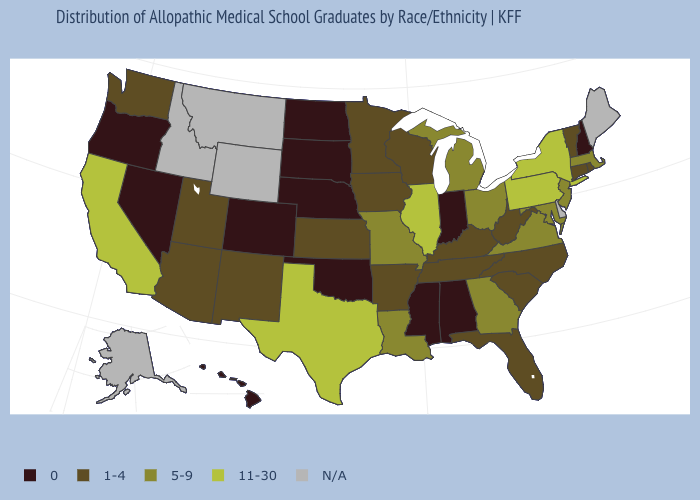Name the states that have a value in the range 1-4?
Concise answer only. Arizona, Arkansas, Connecticut, Florida, Iowa, Kansas, Kentucky, Minnesota, New Mexico, North Carolina, Rhode Island, South Carolina, Tennessee, Utah, Vermont, Washington, West Virginia, Wisconsin. Is the legend a continuous bar?
Be succinct. No. What is the value of Rhode Island?
Keep it brief. 1-4. What is the lowest value in the West?
Answer briefly. 0. Name the states that have a value in the range 5-9?
Quick response, please. Georgia, Louisiana, Maryland, Massachusetts, Michigan, Missouri, New Jersey, Ohio, Virginia. Name the states that have a value in the range 1-4?
Write a very short answer. Arizona, Arkansas, Connecticut, Florida, Iowa, Kansas, Kentucky, Minnesota, New Mexico, North Carolina, Rhode Island, South Carolina, Tennessee, Utah, Vermont, Washington, West Virginia, Wisconsin. What is the value of Tennessee?
Concise answer only. 1-4. Does the first symbol in the legend represent the smallest category?
Concise answer only. Yes. Does Vermont have the lowest value in the Northeast?
Concise answer only. No. Is the legend a continuous bar?
Quick response, please. No. Which states have the lowest value in the USA?
Answer briefly. Alabama, Colorado, Hawaii, Indiana, Mississippi, Nebraska, Nevada, New Hampshire, North Dakota, Oklahoma, Oregon, South Dakota. Name the states that have a value in the range 5-9?
Keep it brief. Georgia, Louisiana, Maryland, Massachusetts, Michigan, Missouri, New Jersey, Ohio, Virginia. 